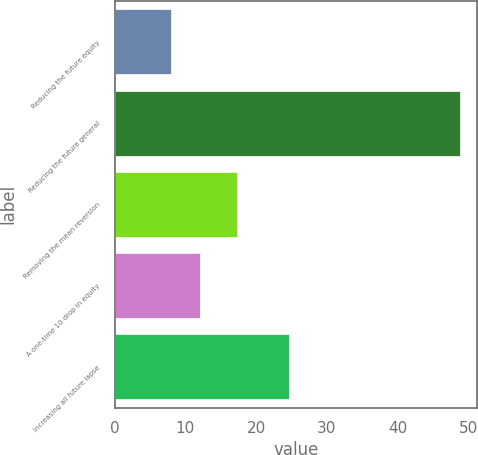Convert chart to OTSL. <chart><loc_0><loc_0><loc_500><loc_500><bar_chart><fcel>Reducing the future equity<fcel>Reducing the future general<fcel>Removing the mean reversion<fcel>A one-time 10 drop in equity<fcel>Increasing all future lapse<nl><fcel>8<fcel>48.8<fcel>17.3<fcel>12.08<fcel>24.7<nl></chart> 